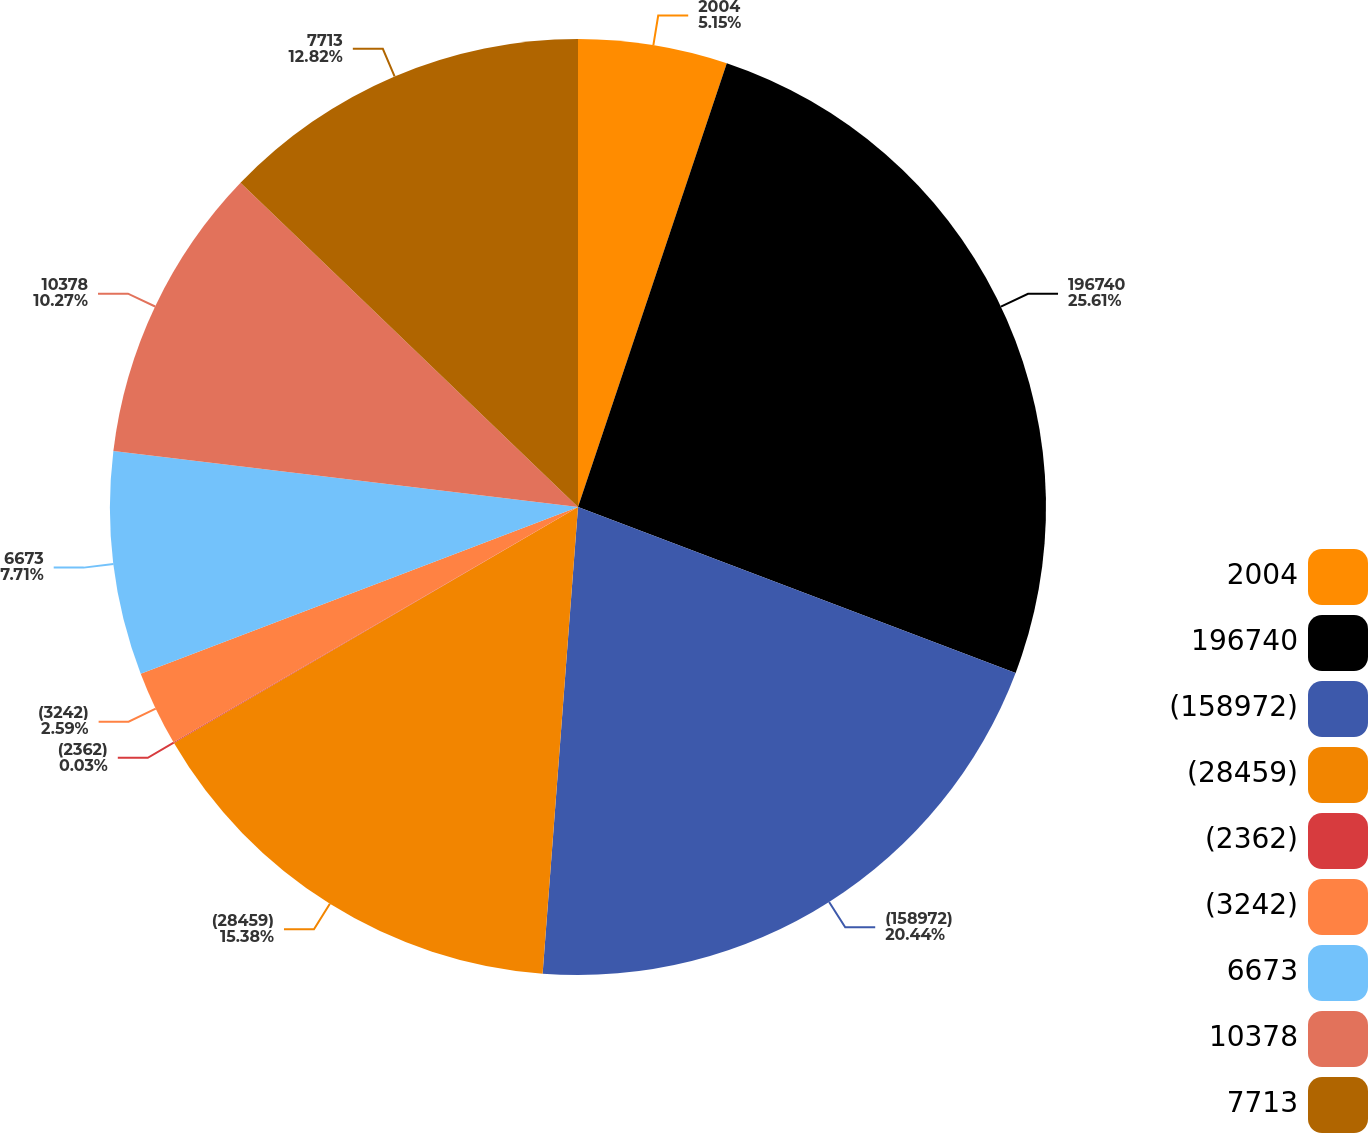Convert chart to OTSL. <chart><loc_0><loc_0><loc_500><loc_500><pie_chart><fcel>2004<fcel>196740<fcel>(158972)<fcel>(28459)<fcel>(2362)<fcel>(3242)<fcel>6673<fcel>10378<fcel>7713<nl><fcel>5.15%<fcel>25.62%<fcel>20.44%<fcel>15.38%<fcel>0.03%<fcel>2.59%<fcel>7.71%<fcel>10.27%<fcel>12.82%<nl></chart> 